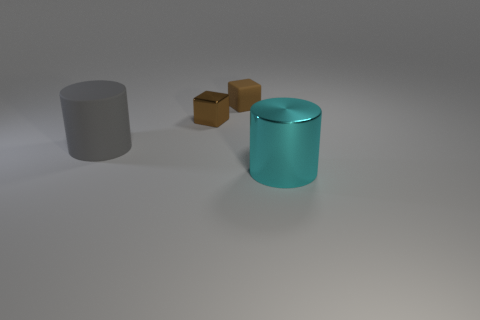What shape is the small object that is the same color as the shiny block?
Give a very brief answer. Cube. How many other things are made of the same material as the large gray object?
Ensure brevity in your answer.  1. What number of tiny things are gray matte objects or shiny things?
Provide a short and direct response. 1. Are the large gray object and the big cyan cylinder made of the same material?
Offer a terse response. No. There is a large object to the left of the small brown matte block; how many large cyan metallic cylinders are on the left side of it?
Your answer should be very brief. 0. Are there any other big metallic objects of the same shape as the big gray thing?
Provide a short and direct response. Yes. Do the metal thing that is left of the brown matte block and the large object that is on the left side of the big cyan metallic cylinder have the same shape?
Provide a short and direct response. No. There is a object that is both in front of the small metal block and left of the large cyan shiny cylinder; what is its shape?
Make the answer very short. Cylinder. Is there a metallic block of the same size as the brown matte thing?
Offer a terse response. Yes. Does the shiny cylinder have the same color as the matte thing right of the big rubber thing?
Provide a short and direct response. No. 